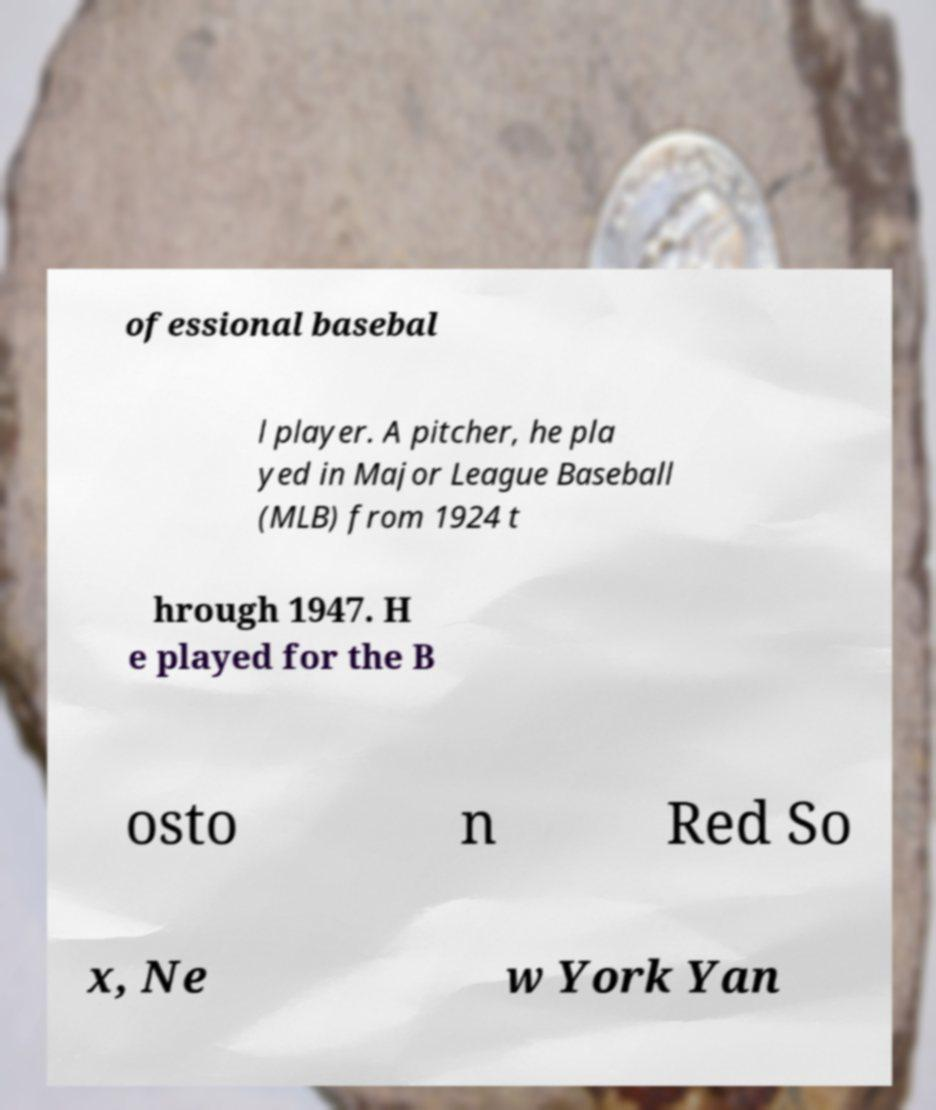For documentation purposes, I need the text within this image transcribed. Could you provide that? ofessional basebal l player. A pitcher, he pla yed in Major League Baseball (MLB) from 1924 t hrough 1947. H e played for the B osto n Red So x, Ne w York Yan 